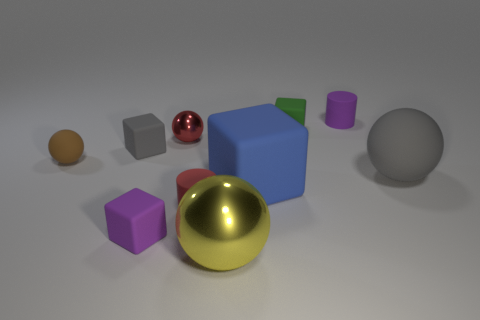Is there a green block that has the same material as the blue thing? Yes, there is a green cube in the image that shares the same matte finish as the blue cube. 